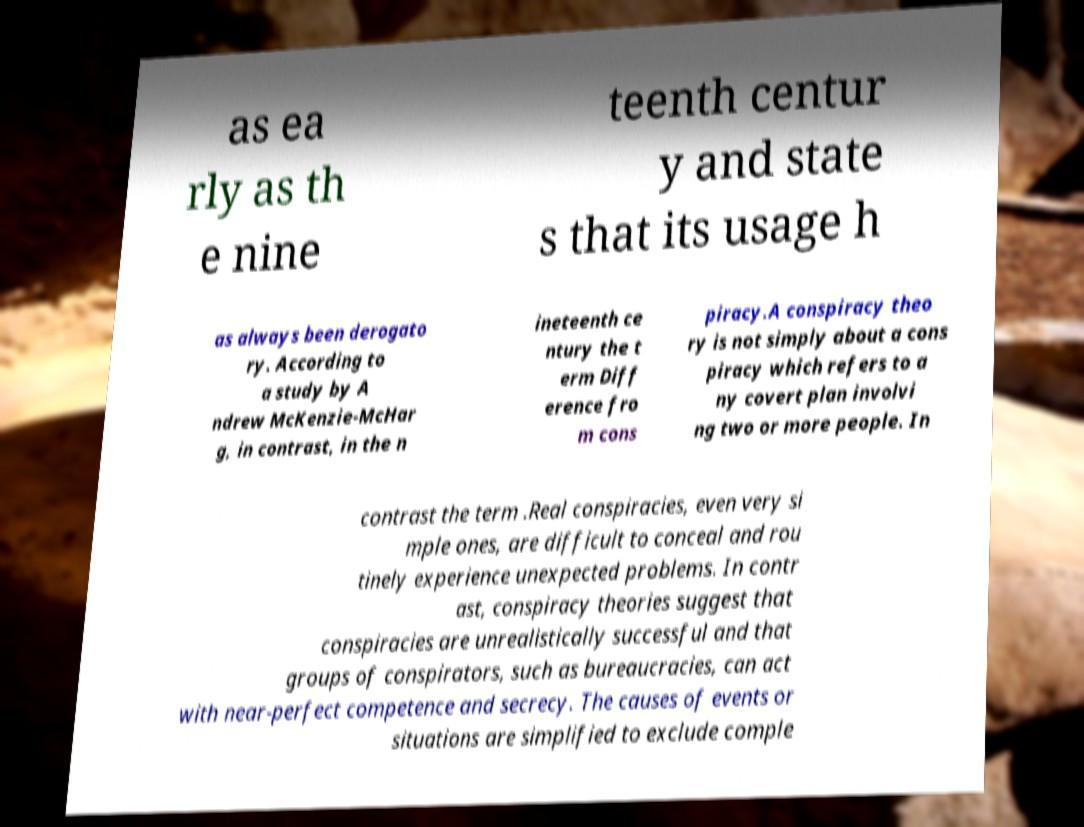I need the written content from this picture converted into text. Can you do that? as ea rly as th e nine teenth centur y and state s that its usage h as always been derogato ry. According to a study by A ndrew McKenzie-McHar g, in contrast, in the n ineteenth ce ntury the t erm Diff erence fro m cons piracy.A conspiracy theo ry is not simply about a cons piracy which refers to a ny covert plan involvi ng two or more people. In contrast the term .Real conspiracies, even very si mple ones, are difficult to conceal and rou tinely experience unexpected problems. In contr ast, conspiracy theories suggest that conspiracies are unrealistically successful and that groups of conspirators, such as bureaucracies, can act with near-perfect competence and secrecy. The causes of events or situations are simplified to exclude comple 